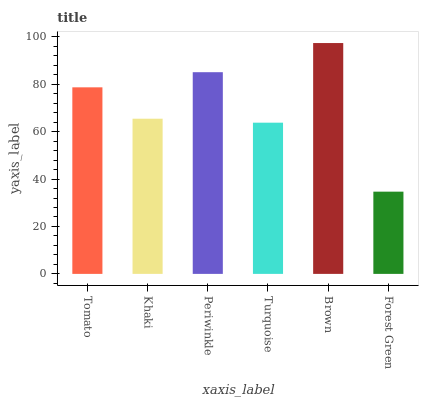Is Forest Green the minimum?
Answer yes or no. Yes. Is Brown the maximum?
Answer yes or no. Yes. Is Khaki the minimum?
Answer yes or no. No. Is Khaki the maximum?
Answer yes or no. No. Is Tomato greater than Khaki?
Answer yes or no. Yes. Is Khaki less than Tomato?
Answer yes or no. Yes. Is Khaki greater than Tomato?
Answer yes or no. No. Is Tomato less than Khaki?
Answer yes or no. No. Is Tomato the high median?
Answer yes or no. Yes. Is Khaki the low median?
Answer yes or no. Yes. Is Brown the high median?
Answer yes or no. No. Is Turquoise the low median?
Answer yes or no. No. 